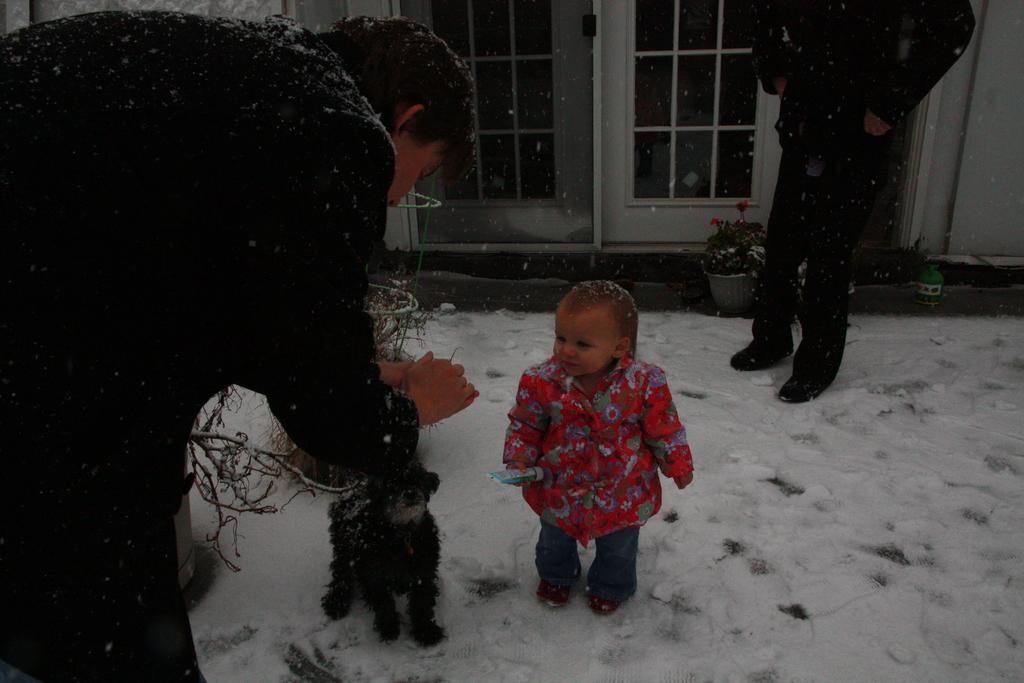In one or two sentences, can you explain what this image depicts? In this image there is a kid holding an object is standing on the surface of the snow, beside the kid there is a small dog in front of the kid there is a person, behind the kid there is another person standing on the surface of the snow, behind the kid there is a glass door and there are flower pots on the surface. 